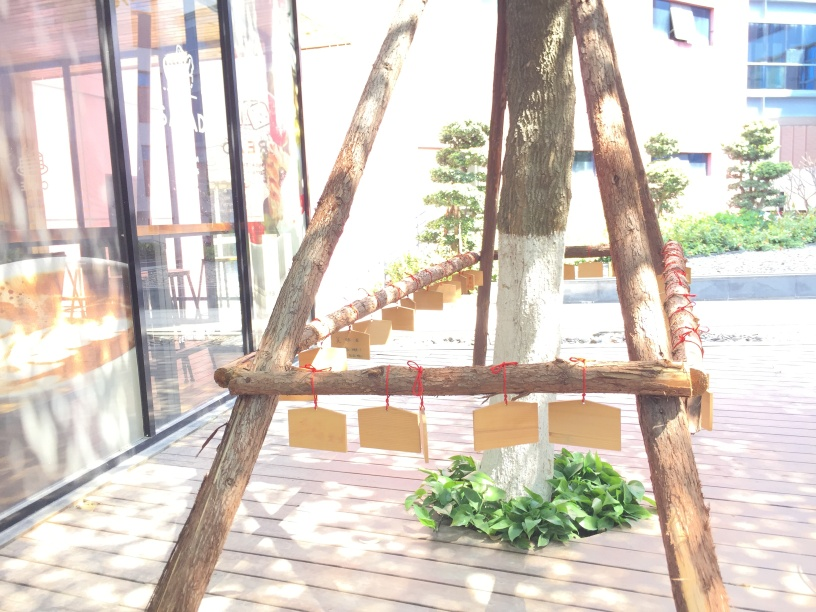What is the purpose of the structure in the image? The wooden structure with suspended cardboard pieces seems to be a form of rustic decoration, possibly for an event or to create an artistic ambiance in the outdoor space it occupies. 